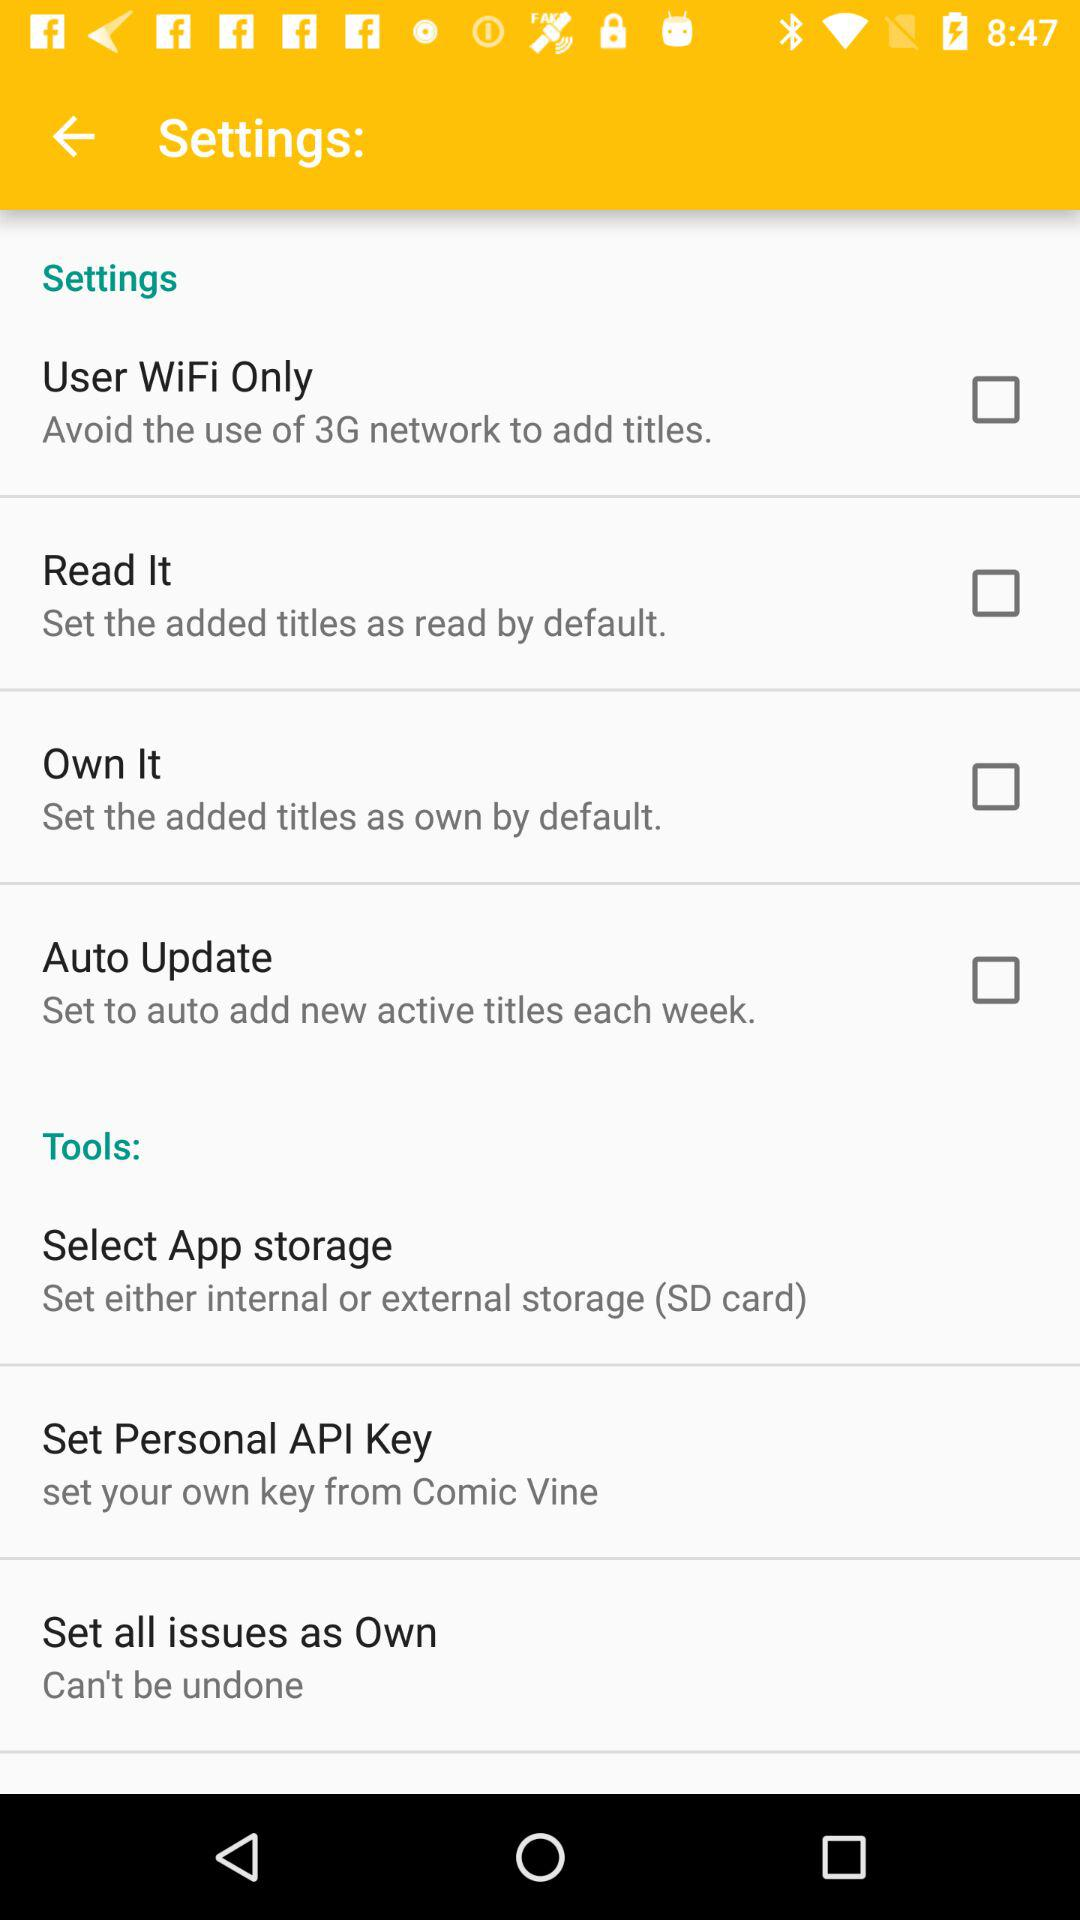How many settings items have checkboxes?
Answer the question using a single word or phrase. 4 